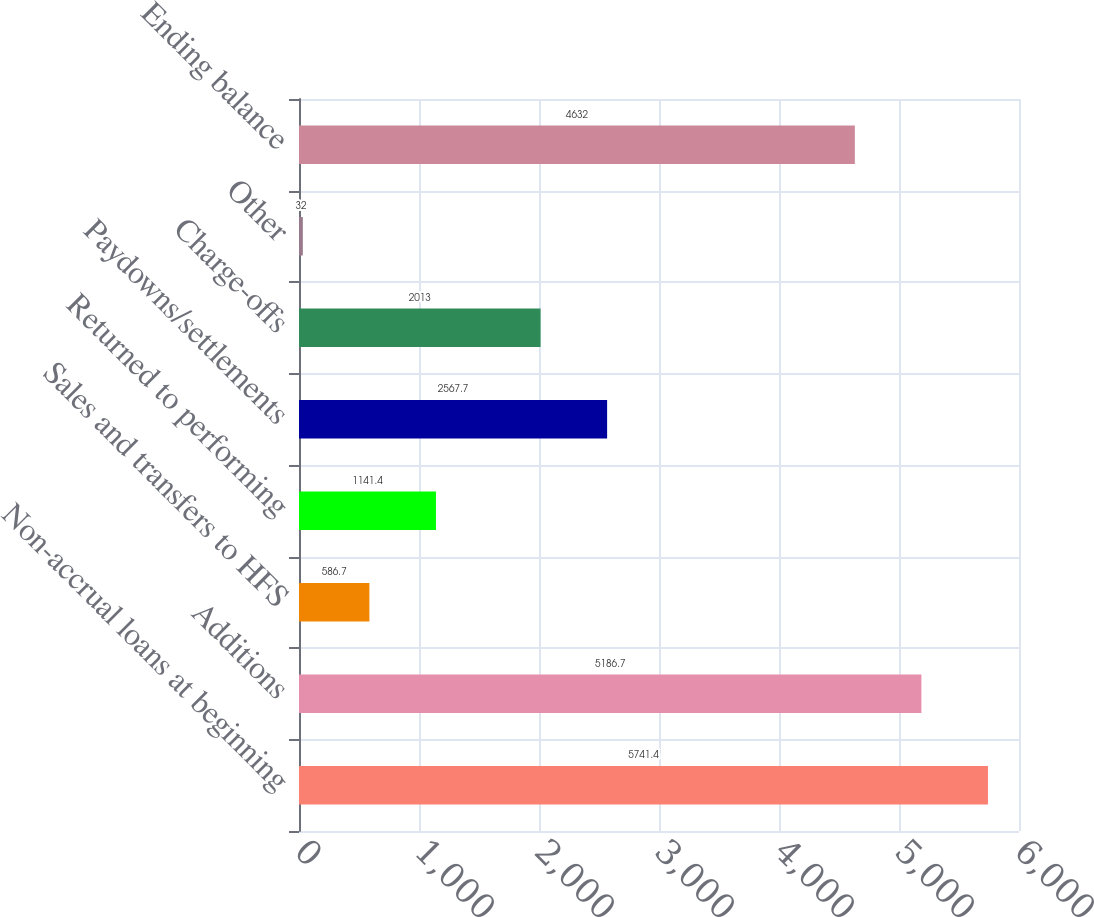Convert chart. <chart><loc_0><loc_0><loc_500><loc_500><bar_chart><fcel>Non-accrual loans at beginning<fcel>Additions<fcel>Sales and transfers to HFS<fcel>Returned to performing<fcel>Paydowns/settlements<fcel>Charge-offs<fcel>Other<fcel>Ending balance<nl><fcel>5741.4<fcel>5186.7<fcel>586.7<fcel>1141.4<fcel>2567.7<fcel>2013<fcel>32<fcel>4632<nl></chart> 